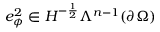<formula> <loc_0><loc_0><loc_500><loc_500>e _ { \phi } ^ { 2 } \in H ^ { - \frac { 1 } { 2 } } \Lambda ^ { n - 1 } ( \partial \Omega )</formula> 